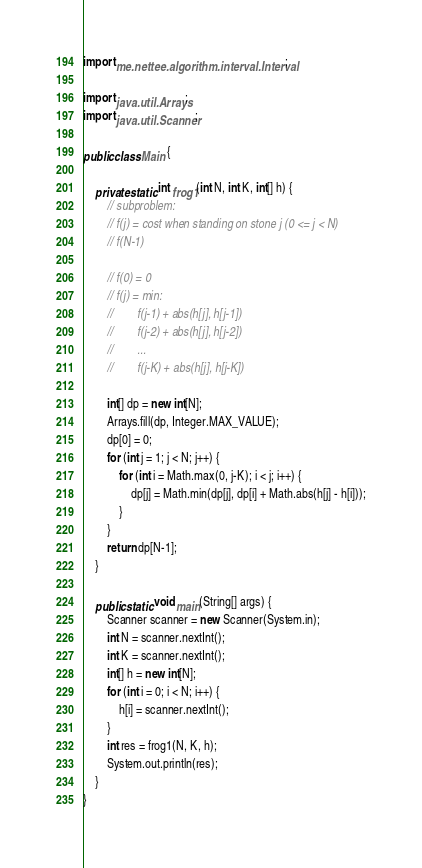Convert code to text. <code><loc_0><loc_0><loc_500><loc_500><_Java_>import me.nettee.algorithm.interval.Interval;

import java.util.Arrays;
import java.util.Scanner;

public class Main {

    private static int frog1(int N, int K, int[] h) {
        // subproblem:
        // f(j) = cost when standing on stone j (0 <= j < N)
        // f(N-1)

        // f(0) = 0
        // f(j) = min:
        //        f(j-1) + abs(h[j], h[j-1])
        //        f(j-2) + abs(h[j], h[j-2])
        //        ...
        //        f(j-K) + abs(h[j], h[j-K])

        int[] dp = new int[N];
        Arrays.fill(dp, Integer.MAX_VALUE);
        dp[0] = 0;
        for (int j = 1; j < N; j++) {
            for (int i = Math.max(0, j-K); i < j; i++) {
                dp[j] = Math.min(dp[j], dp[i] + Math.abs(h[j] - h[i]));
            }
        }
        return dp[N-1];
    }

    public static void main(String[] args) {
        Scanner scanner = new Scanner(System.in);
        int N = scanner.nextInt();
        int K = scanner.nextInt();
        int[] h = new int[N];
        for (int i = 0; i < N; i++) {
            h[i] = scanner.nextInt();
        }
        int res = frog1(N, K, h);
        System.out.println(res);
    }
}
</code> 